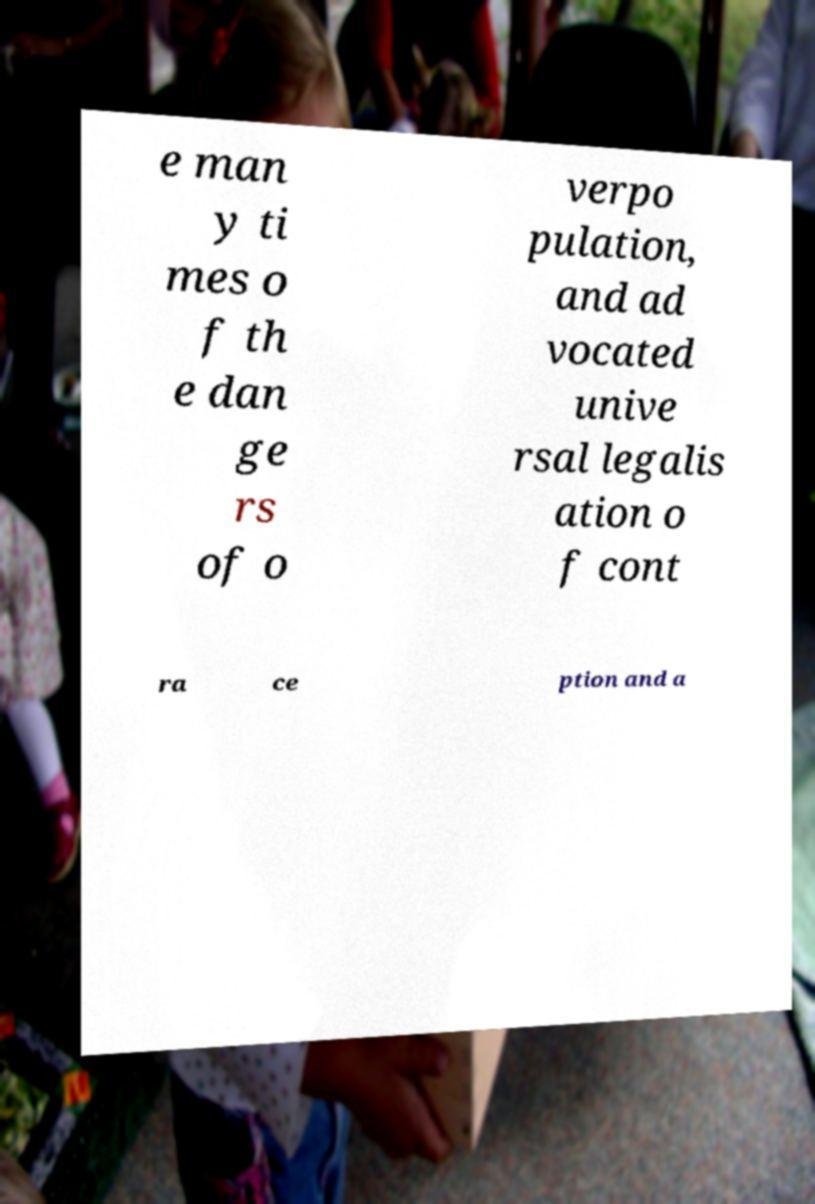What messages or text are displayed in this image? I need them in a readable, typed format. e man y ti mes o f th e dan ge rs of o verpo pulation, and ad vocated unive rsal legalis ation o f cont ra ce ption and a 